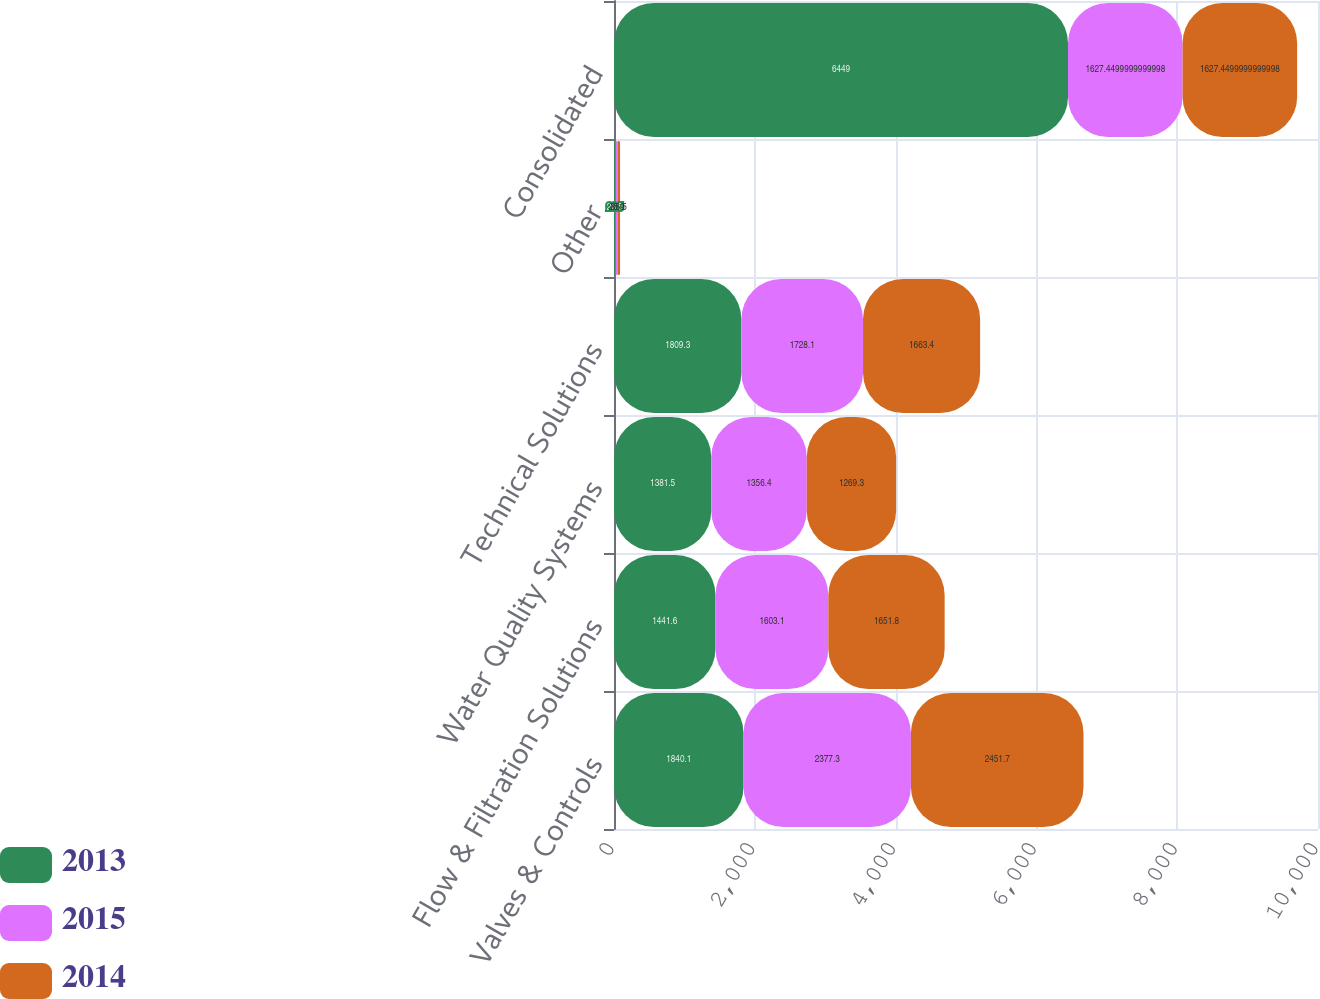<chart> <loc_0><loc_0><loc_500><loc_500><stacked_bar_chart><ecel><fcel>Valves & Controls<fcel>Flow & Filtration Solutions<fcel>Water Quality Systems<fcel>Technical Solutions<fcel>Other<fcel>Consolidated<nl><fcel>2013<fcel>1840.1<fcel>1441.6<fcel>1381.5<fcel>1809.3<fcel>23.5<fcel>6449<nl><fcel>2015<fcel>2377.3<fcel>1603.1<fcel>1356.4<fcel>1728.1<fcel>25.9<fcel>1627.45<nl><fcel>2014<fcel>2451.7<fcel>1651.8<fcel>1269.3<fcel>1663.4<fcel>36.5<fcel>1627.45<nl></chart> 